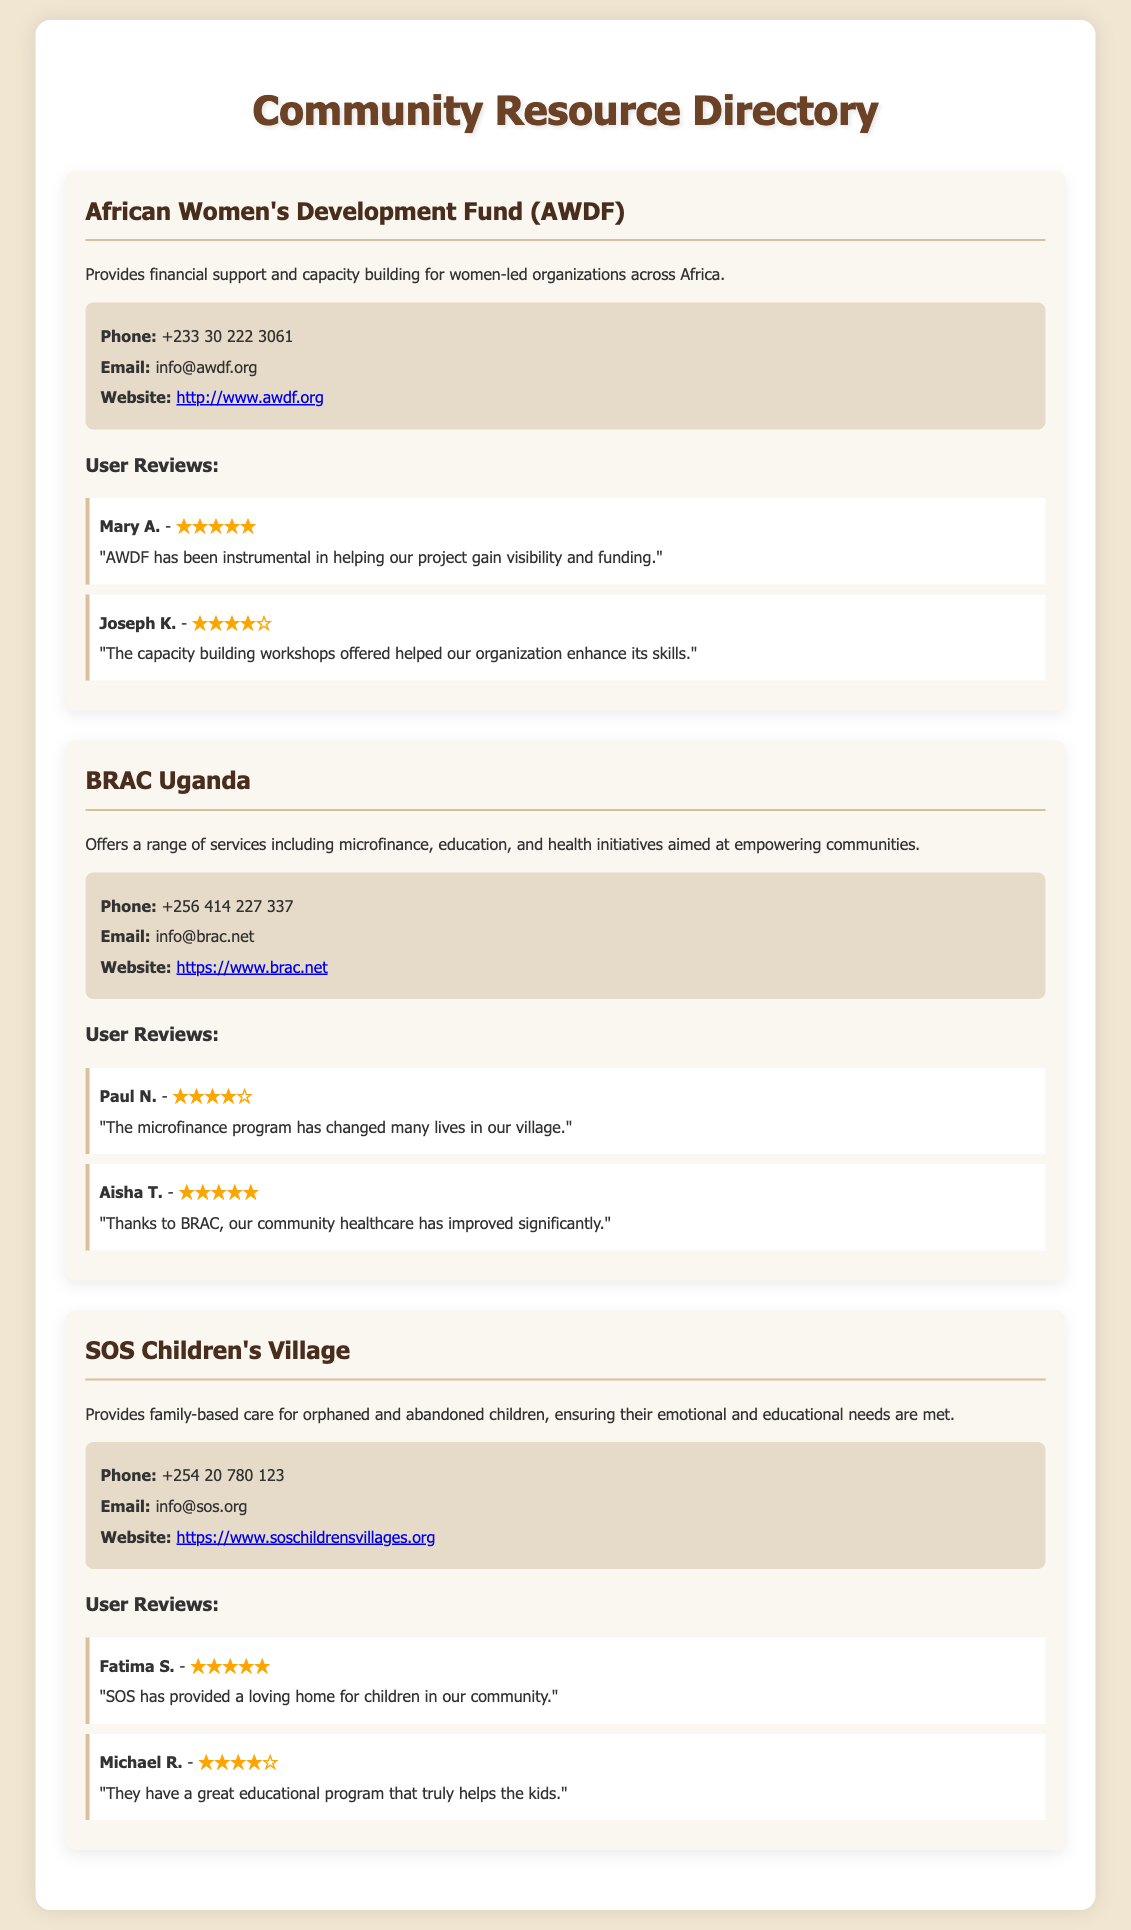What is the name of the first organization listed? The first organization listed in the directory is "African Women's Development Fund (AWDF)."
Answer: African Women's Development Fund (AWDF) What services does BRAC Uganda offer? BRAC Uganda offers microfinance, education, and health initiatives.
Answer: Microfinance, education, and health initiatives What is the phone number for SOS Children’s Village? The document provides the phone number for SOS Children’s Village as +254 20 780 123.
Answer: +254 20 780 123 How many stars did Mary A. give to AWDF? Mary A. rated AWDF with five stars in her review.
Answer: ★★★★★ Which organization focuses on orphaned and abandoned children? The organization that focuses on orphaned and abandoned children is SOS Children's Village.
Answer: SOS Children's Village What is the main goal of the African Women's Development Fund? The main goal is to provide financial support and capacity building for women-led organizations across Africa.
Answer: Financial support and capacity building for women-led organizations Who reviewed BRAC Uganda and rated it five stars? Aisha T. reviewed BRAC Uganda and rated it five stars.
Answer: Aisha T What is the website for SOS Children’s Village? The website for SOS Children’s Village is https://www.soschildrensvillages.org.
Answer: https://www.soschildrensvillages.org 